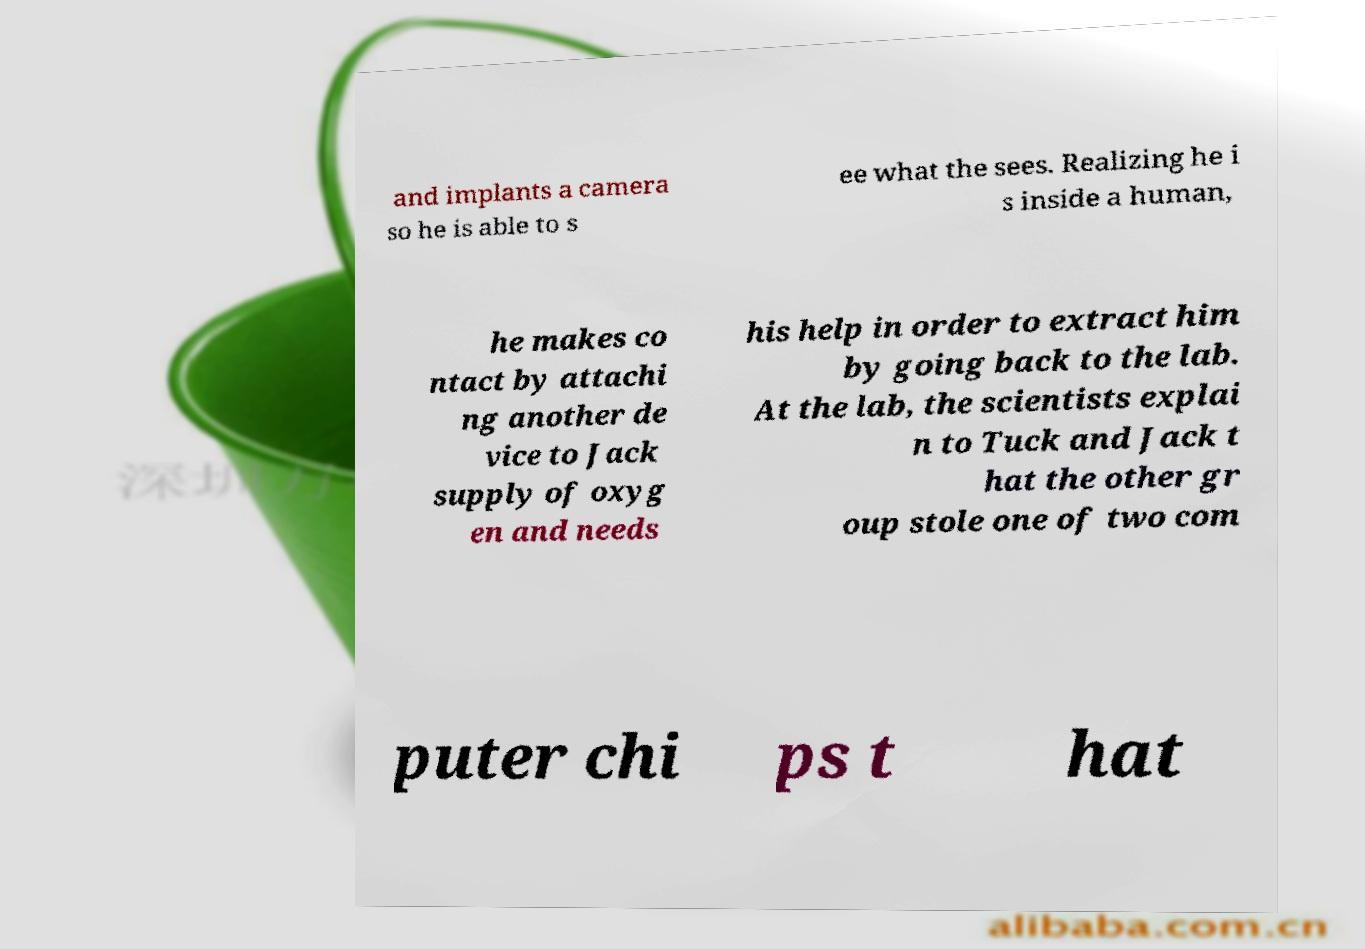Please read and relay the text visible in this image. What does it say? and implants a camera so he is able to s ee what the sees. Realizing he i s inside a human, he makes co ntact by attachi ng another de vice to Jack supply of oxyg en and needs his help in order to extract him by going back to the lab. At the lab, the scientists explai n to Tuck and Jack t hat the other gr oup stole one of two com puter chi ps t hat 